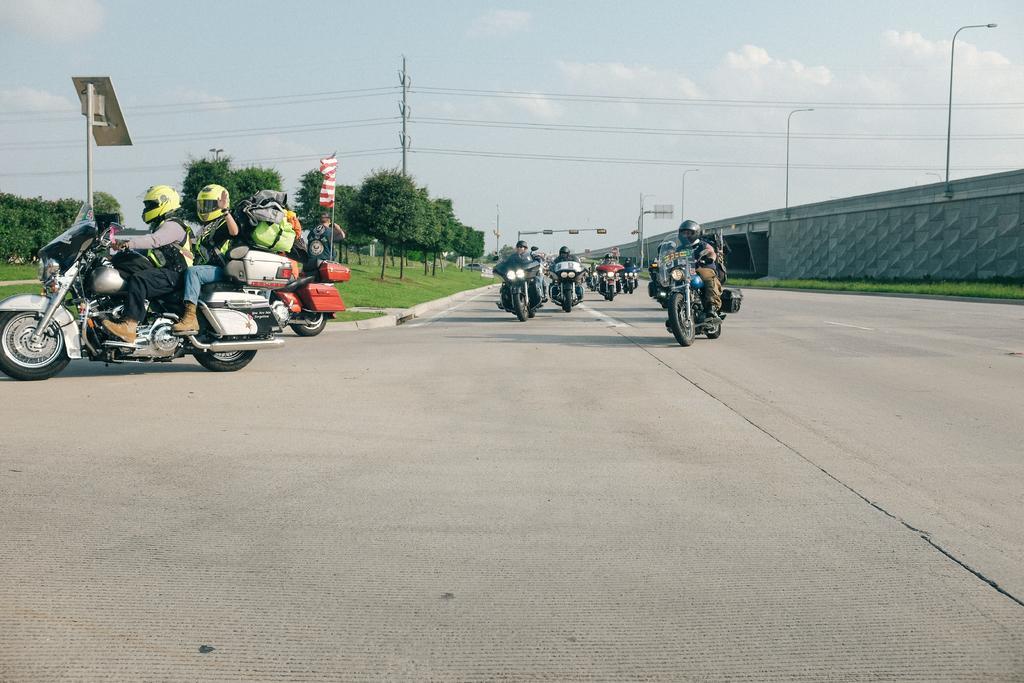Describe this image in one or two sentences. This picture is clicked outside. In the center we can see the group of persons riding bikes. In the background we can see the sky, lights attached to the poles and we can see the cables, trees, flag, green grass, bridge and many other objects. 